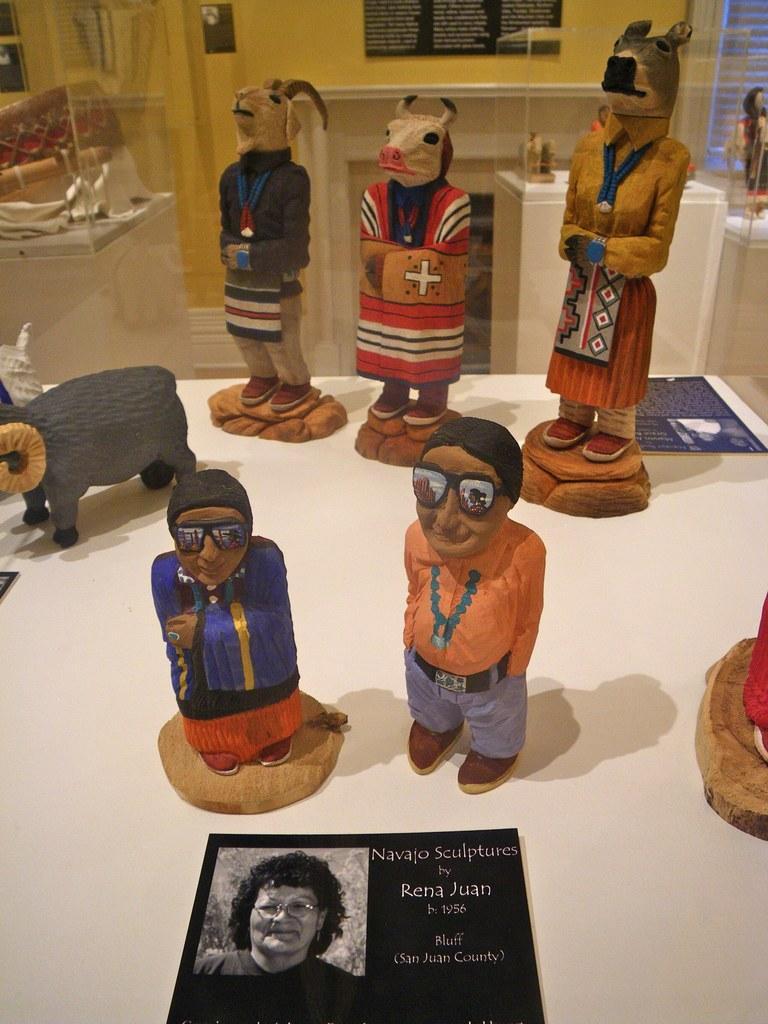In one or two sentences, can you explain what this image depicts? In the image on the table there are toys and also there is a black paper with a lady image and something is written on it. Behind the table there are few objects inside the glass boxes. In the background on the wall there is a black poster with something written on it. 